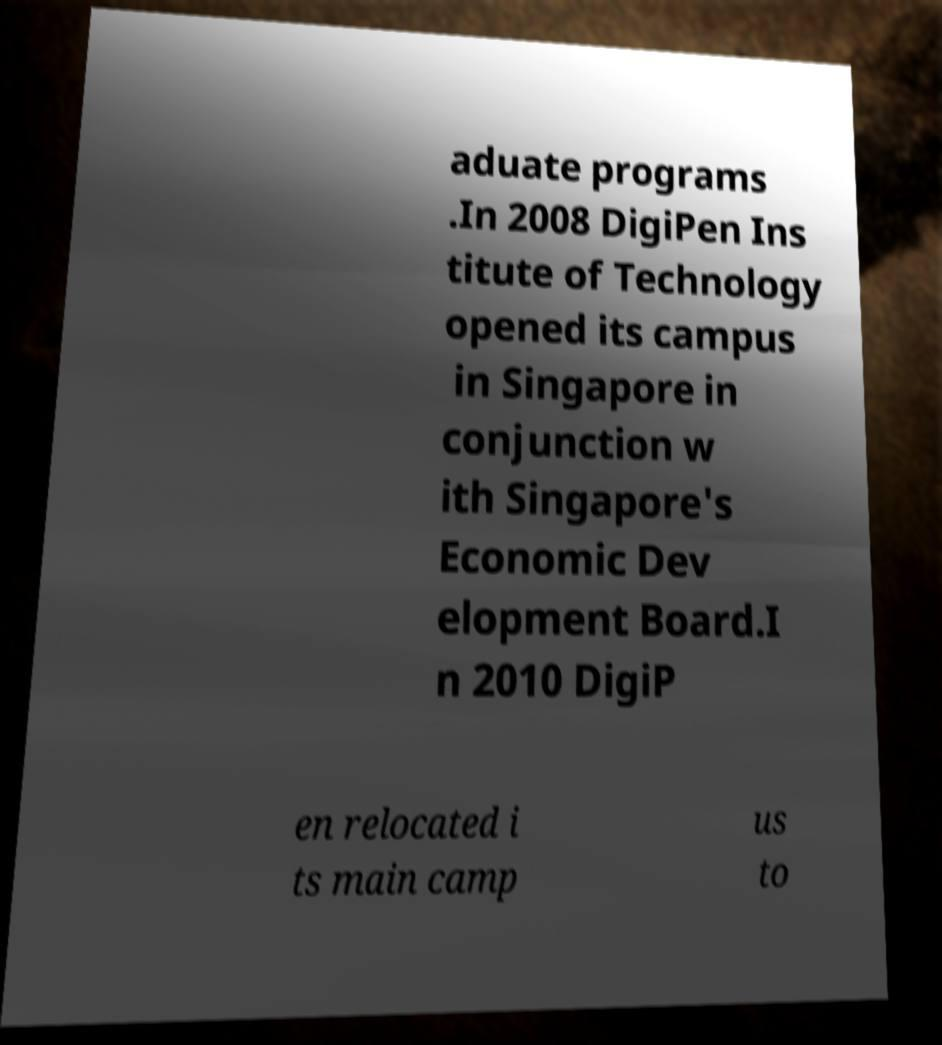There's text embedded in this image that I need extracted. Can you transcribe it verbatim? aduate programs .In 2008 DigiPen Ins titute of Technology opened its campus in Singapore in conjunction w ith Singapore's Economic Dev elopment Board.I n 2010 DigiP en relocated i ts main camp us to 